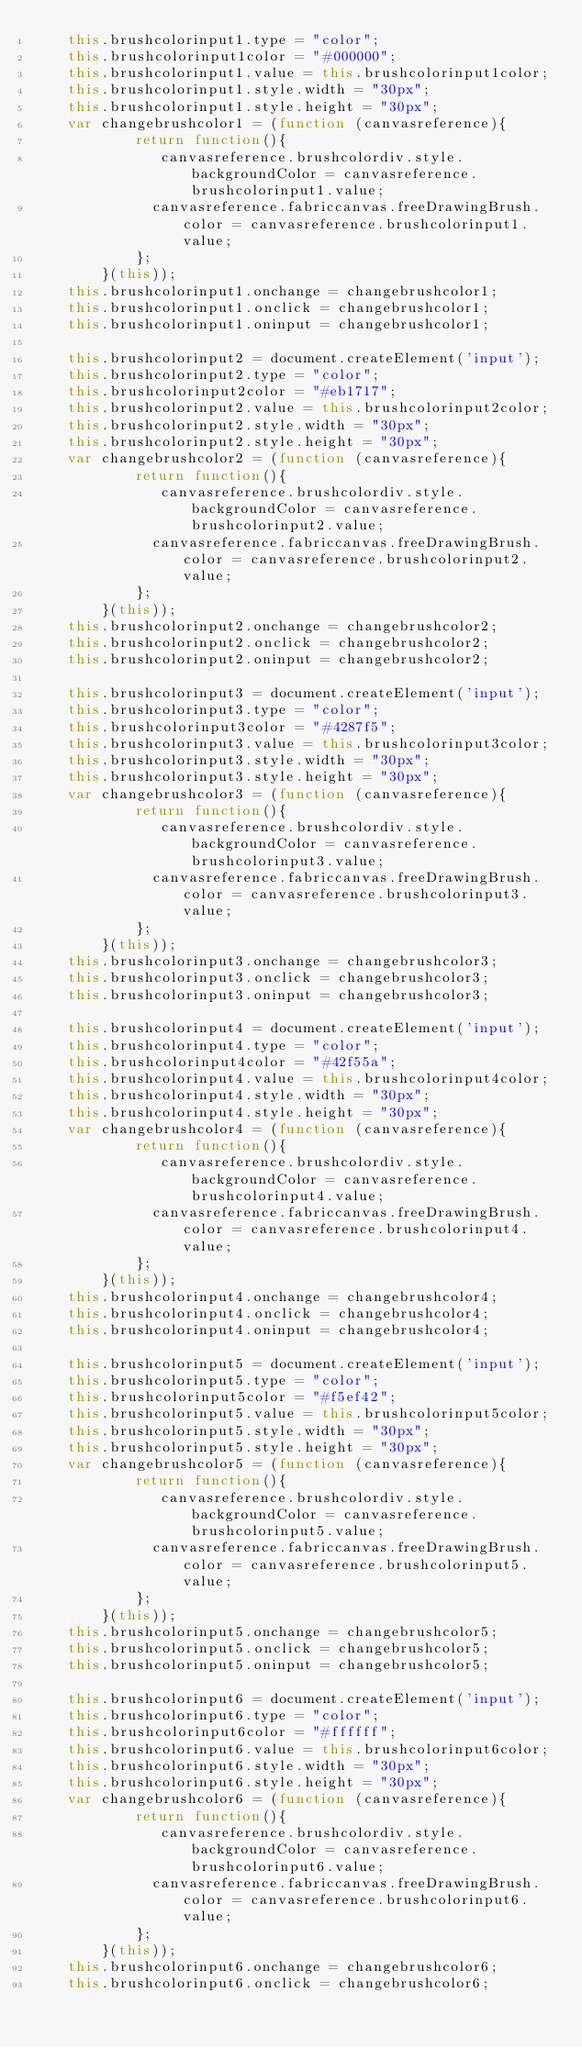Convert code to text. <code><loc_0><loc_0><loc_500><loc_500><_JavaScript_>		this.brushcolorinput1.type = "color";
		this.brushcolorinput1color = "#000000";
		this.brushcolorinput1.value = this.brushcolorinput1color;
		this.brushcolorinput1.style.width = "30px";
		this.brushcolorinput1.style.height = "30px";
		var changebrushcolor1 = (function (canvasreference){
						return function(){
						   canvasreference.brushcolordiv.style.backgroundColor = canvasreference.brushcolorinput1.value;
							canvasreference.fabriccanvas.freeDrawingBrush.color = canvasreference.brushcolorinput1.value;
						};
				}(this));
		this.brushcolorinput1.onchange = changebrushcolor1;
		this.brushcolorinput1.onclick = changebrushcolor1;
		this.brushcolorinput1.oninput = changebrushcolor1;

		this.brushcolorinput2 = document.createElement('input');
		this.brushcolorinput2.type = "color";
		this.brushcolorinput2color = "#eb1717";
		this.brushcolorinput2.value = this.brushcolorinput2color;
		this.brushcolorinput2.style.width = "30px";
		this.brushcolorinput2.style.height = "30px";
		var changebrushcolor2 = (function (canvasreference){
						return function(){
						   canvasreference.brushcolordiv.style.backgroundColor = canvasreference.brushcolorinput2.value;
							canvasreference.fabriccanvas.freeDrawingBrush.color = canvasreference.brushcolorinput2.value;
						};
				}(this));
		this.brushcolorinput2.onchange = changebrushcolor2;
		this.brushcolorinput2.onclick = changebrushcolor2;
		this.brushcolorinput2.oninput = changebrushcolor2;

		this.brushcolorinput3 = document.createElement('input');
		this.brushcolorinput3.type = "color";
		this.brushcolorinput3color = "#4287f5";
		this.brushcolorinput3.value = this.brushcolorinput3color;
		this.brushcolorinput3.style.width = "30px";
		this.brushcolorinput3.style.height = "30px";
		var changebrushcolor3 = (function (canvasreference){
						return function(){
						   canvasreference.brushcolordiv.style.backgroundColor = canvasreference.brushcolorinput3.value;
							canvasreference.fabriccanvas.freeDrawingBrush.color = canvasreference.brushcolorinput3.value;
						};
				}(this));
		this.brushcolorinput3.onchange = changebrushcolor3;
		this.brushcolorinput3.onclick = changebrushcolor3;
		this.brushcolorinput3.oninput = changebrushcolor3;

		this.brushcolorinput4 = document.createElement('input');
		this.brushcolorinput4.type = "color";
		this.brushcolorinput4color = "#42f55a";
		this.brushcolorinput4.value = this.brushcolorinput4color;
		this.brushcolorinput4.style.width = "30px";
		this.brushcolorinput4.style.height = "30px";
		var changebrushcolor4 = (function (canvasreference){
						return function(){
						   canvasreference.brushcolordiv.style.backgroundColor = canvasreference.brushcolorinput4.value;
							canvasreference.fabriccanvas.freeDrawingBrush.color = canvasreference.brushcolorinput4.value;
						};
				}(this));
		this.brushcolorinput4.onchange = changebrushcolor4;
		this.brushcolorinput4.onclick = changebrushcolor4;
		this.brushcolorinput4.oninput = changebrushcolor4;

		this.brushcolorinput5 = document.createElement('input');
		this.brushcolorinput5.type = "color";
		this.brushcolorinput5color = "#f5ef42";
		this.brushcolorinput5.value = this.brushcolorinput5color;
		this.brushcolorinput5.style.width = "30px";
		this.brushcolorinput5.style.height = "30px";
		var changebrushcolor5 = (function (canvasreference){
						return function(){
						   canvasreference.brushcolordiv.style.backgroundColor = canvasreference.brushcolorinput5.value;
							canvasreference.fabriccanvas.freeDrawingBrush.color = canvasreference.brushcolorinput5.value;
						};
				}(this));
		this.brushcolorinput5.onchange = changebrushcolor5;
		this.brushcolorinput5.onclick = changebrushcolor5;
		this.brushcolorinput5.oninput = changebrushcolor5;

		this.brushcolorinput6 = document.createElement('input');
		this.brushcolorinput6.type = "color";
		this.brushcolorinput6color = "#ffffff";
		this.brushcolorinput6.value = this.brushcolorinput6color;
		this.brushcolorinput6.style.width = "30px";
		this.brushcolorinput6.style.height = "30px";
		var changebrushcolor6 = (function (canvasreference){
						return function(){
						   canvasreference.brushcolordiv.style.backgroundColor = canvasreference.brushcolorinput6.value;
							canvasreference.fabriccanvas.freeDrawingBrush.color = canvasreference.brushcolorinput6.value;
						};
				}(this));
		this.brushcolorinput6.onchange = changebrushcolor6;
		this.brushcolorinput6.onclick = changebrushcolor6;</code> 